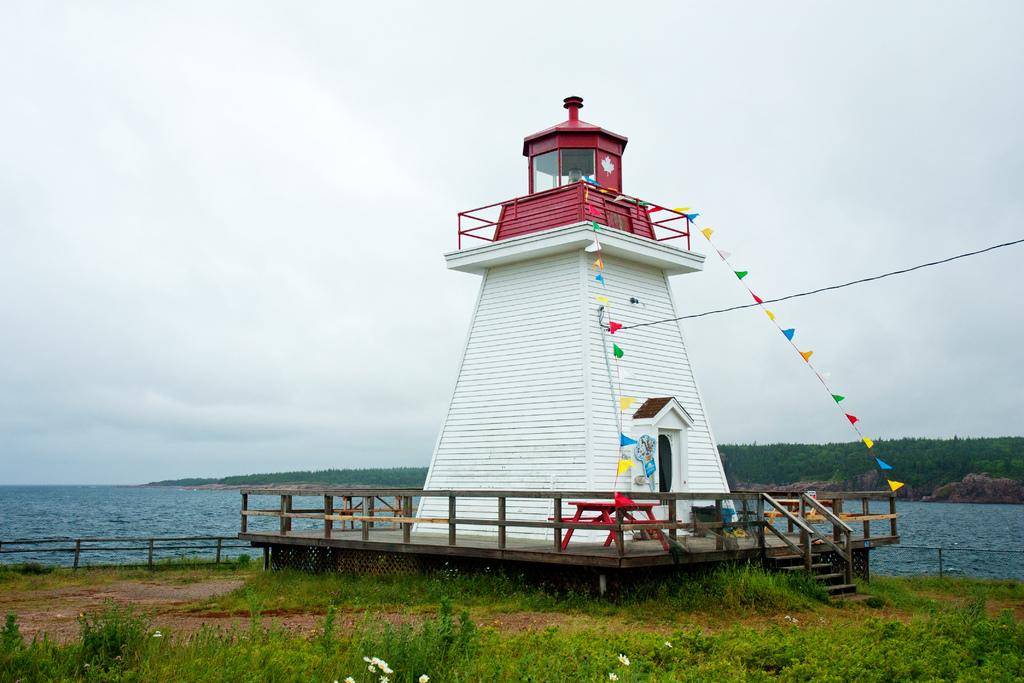What location is depicted in the image? The image depicts Neil's harbor. What type of vegetation can be seen in the image? There are plants with flowers and a group of trees visible in the image. What natural feature is present in the image? There is a large water body in the image. What type of terrain is visible in the image? Grass is present in the image. What man-made structure can be seen in the image? There is a fence in the image. How would you describe the sky in the image? The sky appears cloudy in the image. What type of grip does the mine have in the image? There is no mine present in the image. 